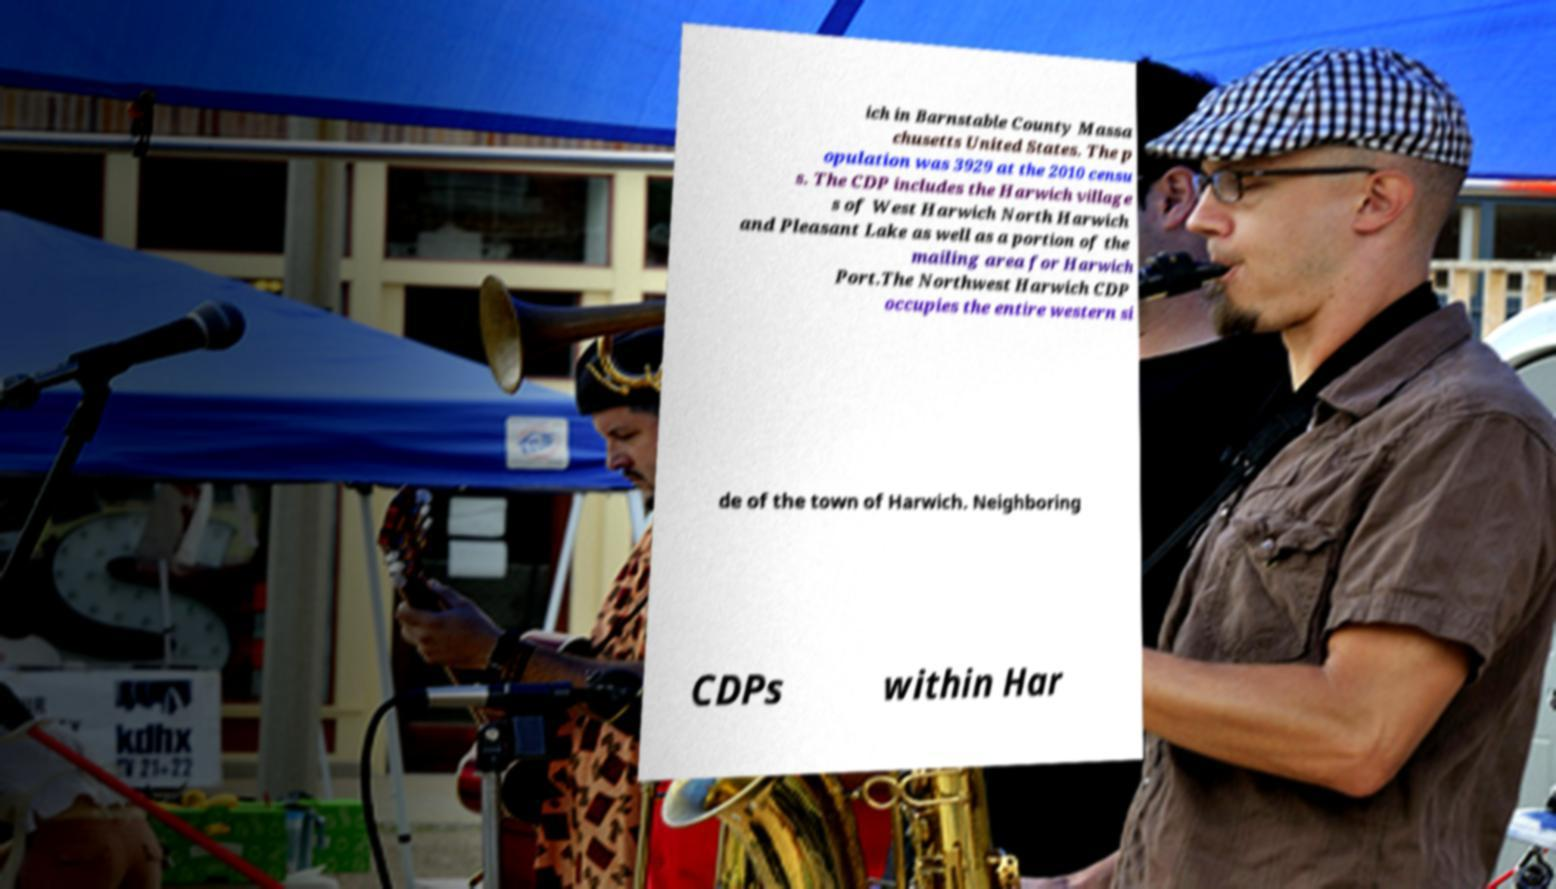Could you assist in decoding the text presented in this image and type it out clearly? ich in Barnstable County Massa chusetts United States. The p opulation was 3929 at the 2010 censu s. The CDP includes the Harwich village s of West Harwich North Harwich and Pleasant Lake as well as a portion of the mailing area for Harwich Port.The Northwest Harwich CDP occupies the entire western si de of the town of Harwich. Neighboring CDPs within Har 